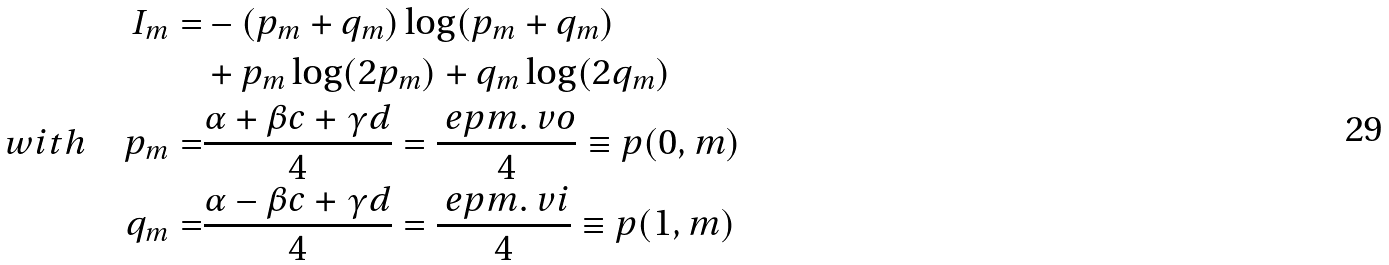<formula> <loc_0><loc_0><loc_500><loc_500>I _ { m } = & - ( p _ { m } + q _ { m } ) \log ( p _ { m } + q _ { m } ) \\ & + p _ { m } \log ( 2 p _ { m } ) + q _ { m } \log ( 2 q _ { m } ) \\ w i t h \quad p _ { m } = & \frac { \alpha + \beta c + \gamma d } { 4 } = \frac { \ e p m . \ v o } { 4 } \equiv p ( 0 , m ) \\ q _ { m } = & \frac { \alpha - \beta c + \gamma d } { 4 } = \frac { \ e p m . \ v i } { 4 } \equiv p ( 1 , m )</formula> 